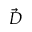<formula> <loc_0><loc_0><loc_500><loc_500>\vec { D }</formula> 